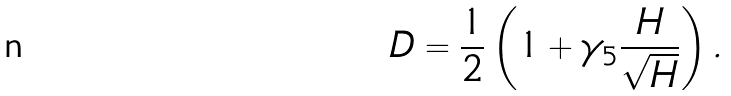<formula> <loc_0><loc_0><loc_500><loc_500>D = \frac { 1 } { 2 } \left ( 1 + \gamma _ { 5 } \frac { H } { \sqrt { H } } \right ) .</formula> 